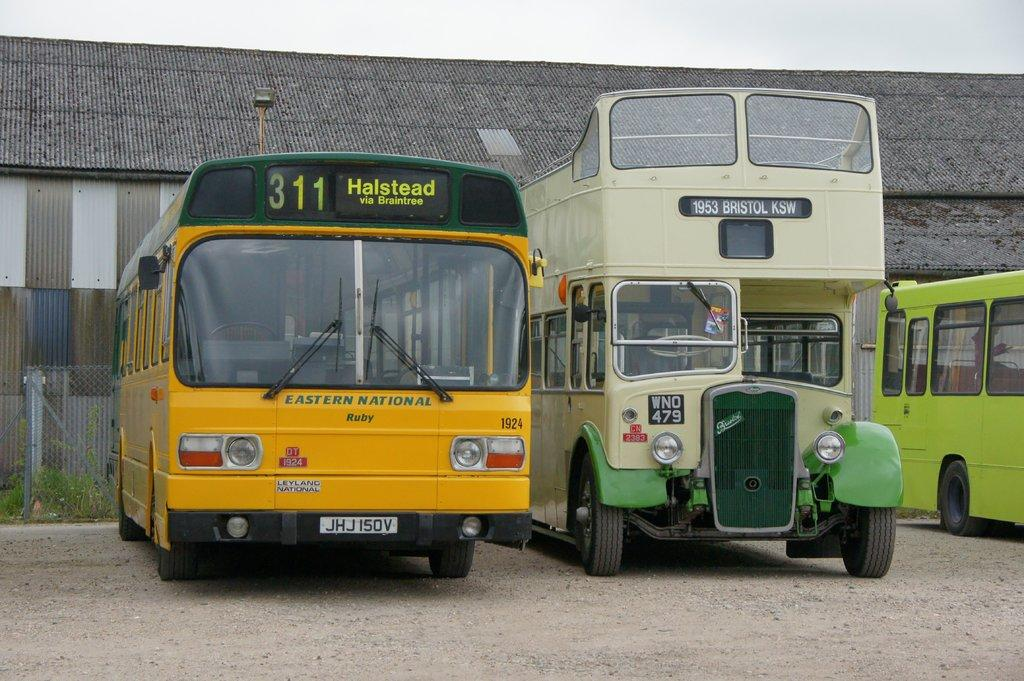What types of objects are present in the image? There are vehicles, a fence, plants, and a shed in the image. Can you describe the fence in the image? The fence is a structure that separates or encloses areas in the image. What can be seen in the background of the image? The sky is visible in the background of the image. What type of structure is the shed in the image? The shed is a small, typically single-story building used for storage or shelter. What type of engine can be heard running in the image? There is no engine running in the image, as it is a still image and not a video or audio recording. What type of exchange is taking place between the plants in the image? There is no exchange taking place between the plants in the image, as plants do not engage in exchanges like humans do. 